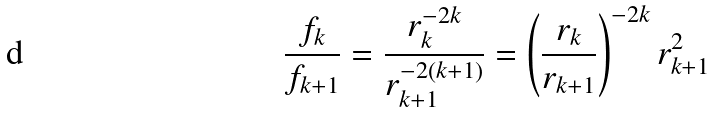<formula> <loc_0><loc_0><loc_500><loc_500>\frac { f _ { k } } { f _ { k + 1 } } = \frac { r _ { k } ^ { - 2 k } } { r _ { k + 1 } ^ { - 2 ( k + 1 ) } } = \left ( \frac { r _ { k } } { r _ { k + 1 } } \right ) ^ { - 2 k } r _ { k + 1 } ^ { 2 }</formula> 